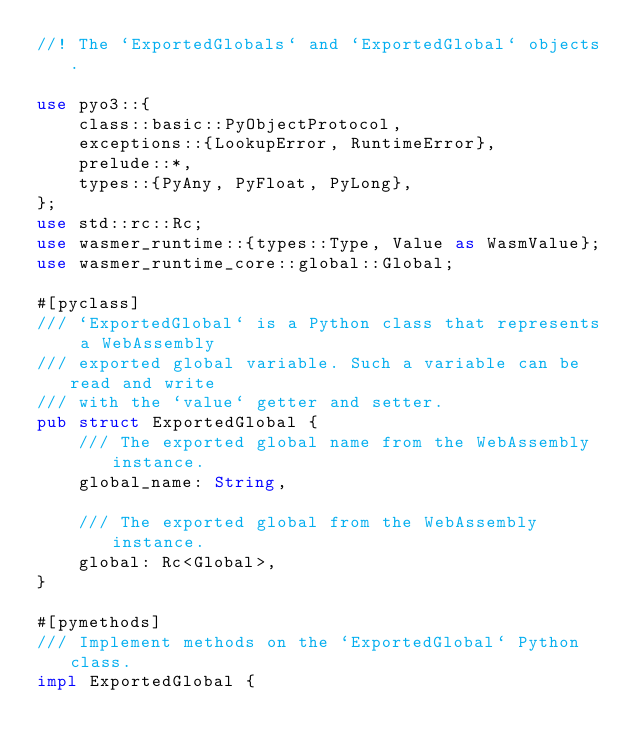<code> <loc_0><loc_0><loc_500><loc_500><_Rust_>//! The `ExportedGlobals` and `ExportedGlobal` objects.

use pyo3::{
    class::basic::PyObjectProtocol,
    exceptions::{LookupError, RuntimeError},
    prelude::*,
    types::{PyAny, PyFloat, PyLong},
};
use std::rc::Rc;
use wasmer_runtime::{types::Type, Value as WasmValue};
use wasmer_runtime_core::global::Global;

#[pyclass]
/// `ExportedGlobal` is a Python class that represents a WebAssembly
/// exported global variable. Such a variable can be read and write
/// with the `value` getter and setter.
pub struct ExportedGlobal {
    /// The exported global name from the WebAssembly instance.
    global_name: String,

    /// The exported global from the WebAssembly instance.
    global: Rc<Global>,
}

#[pymethods]
/// Implement methods on the `ExportedGlobal` Python class.
impl ExportedGlobal {</code> 